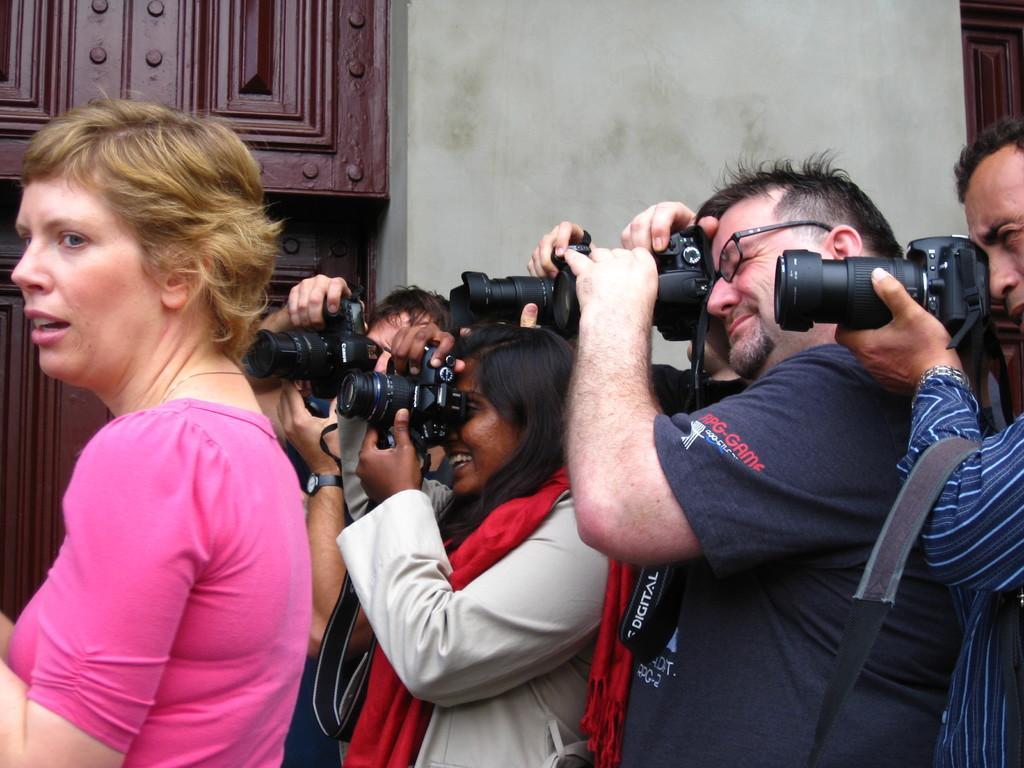Describe this image in one or two sentences. In this picture we can see man and woman standing holding cameras in their hands and clicking pictures here woman standing and in background we can see wall, wooden cupboard. 